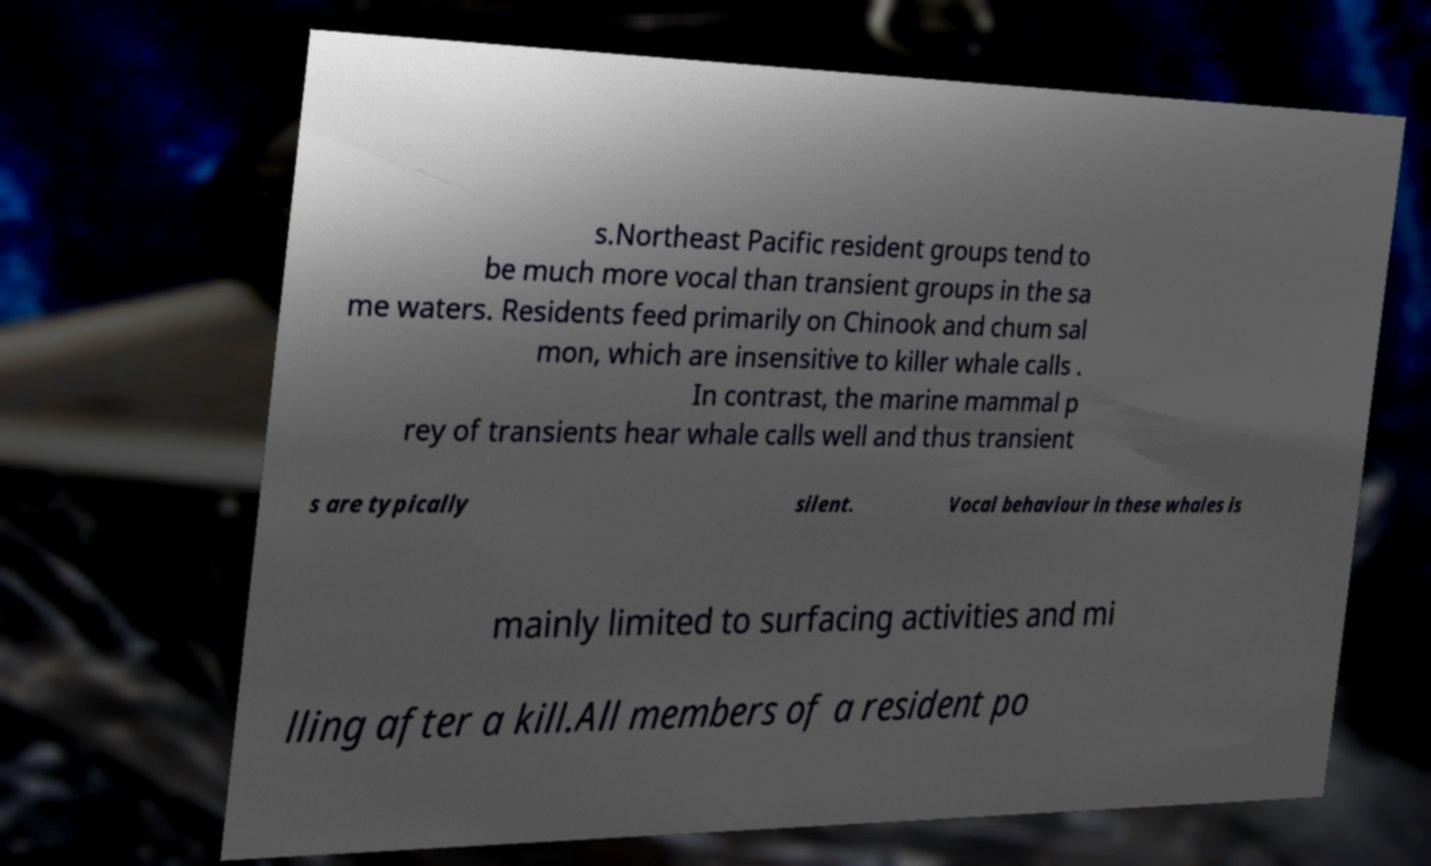What messages or text are displayed in this image? I need them in a readable, typed format. s.Northeast Pacific resident groups tend to be much more vocal than transient groups in the sa me waters. Residents feed primarily on Chinook and chum sal mon, which are insensitive to killer whale calls . In contrast, the marine mammal p rey of transients hear whale calls well and thus transient s are typically silent. Vocal behaviour in these whales is mainly limited to surfacing activities and mi lling after a kill.All members of a resident po 